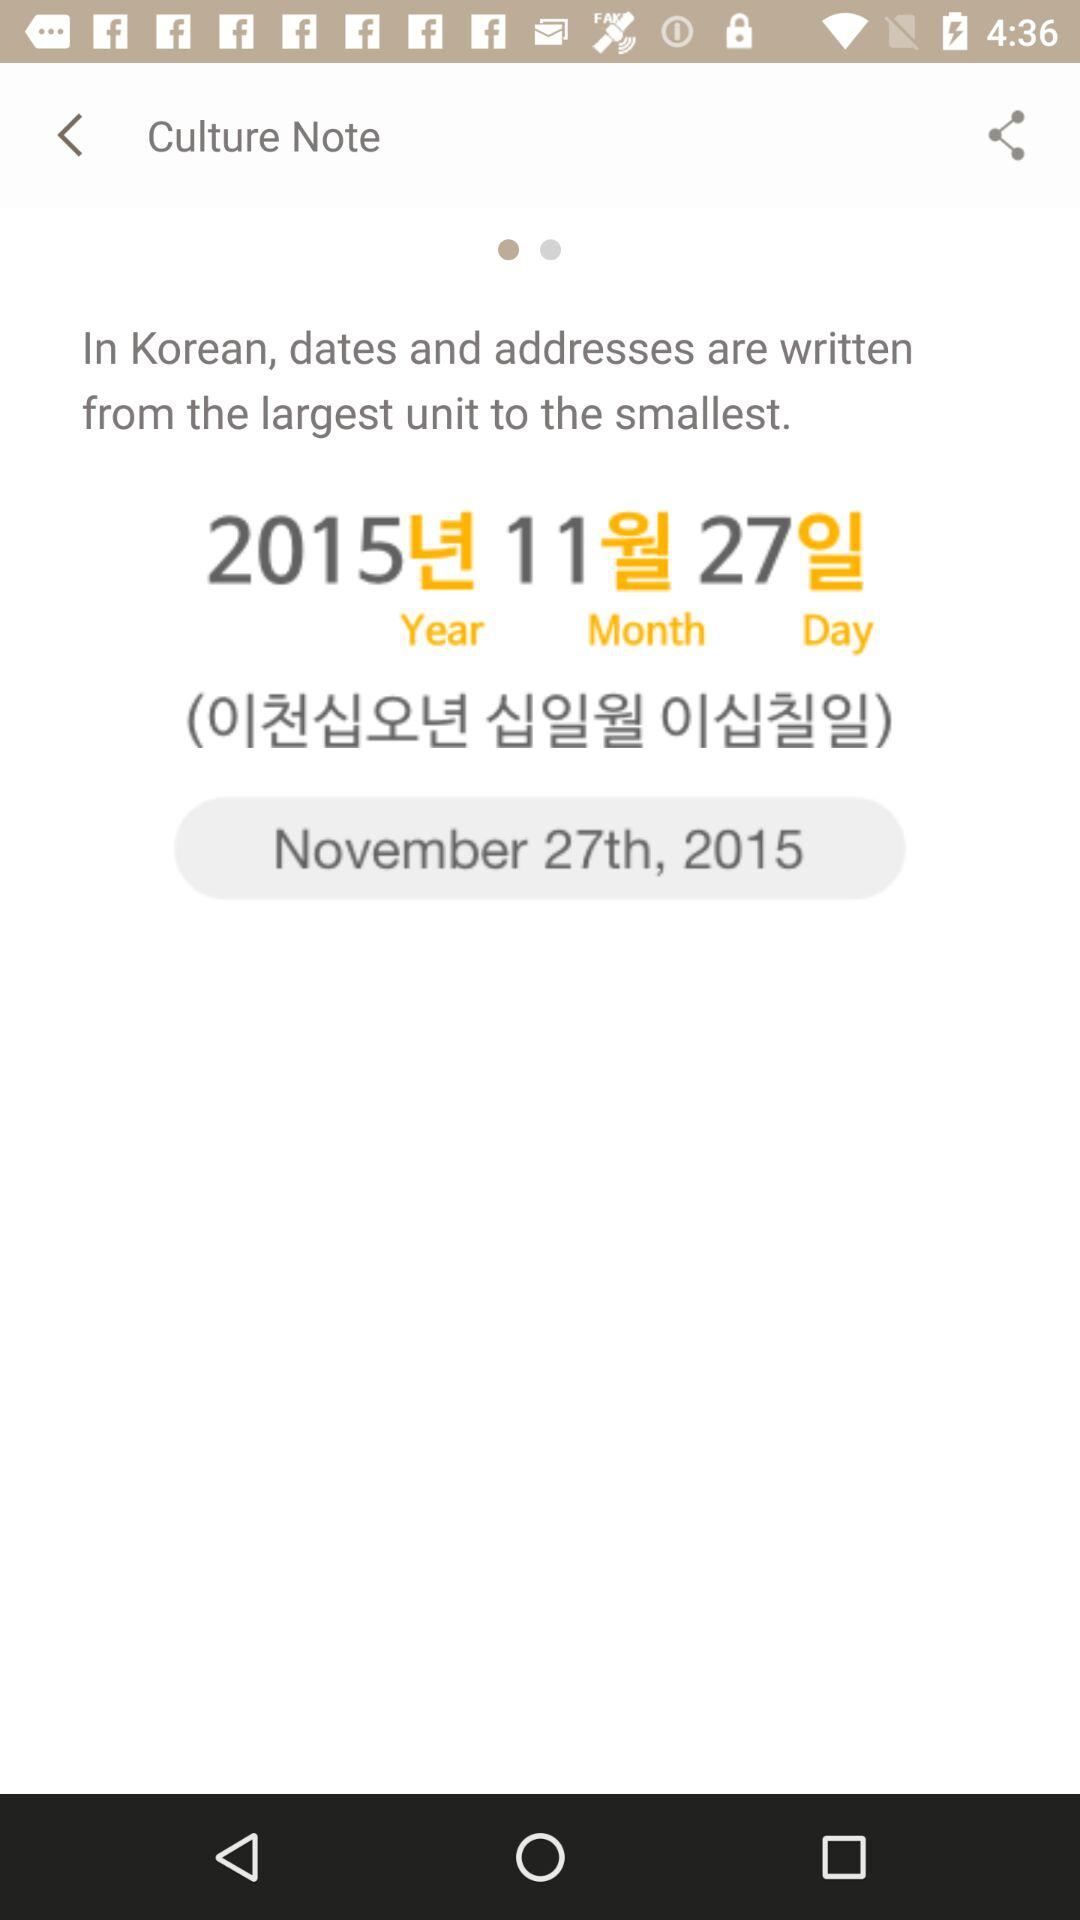What is the mentioned date? The mentioned date is November 27, 2015. 